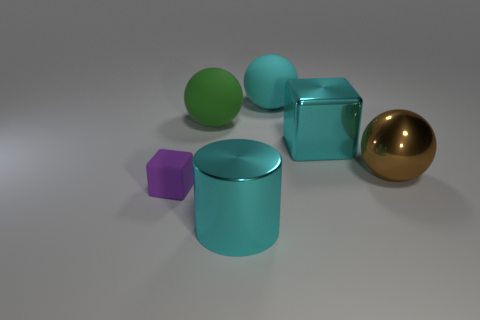Add 4 large cyan objects. How many objects exist? 10 Subtract all cylinders. How many objects are left? 5 Add 5 big metallic cylinders. How many big metallic cylinders exist? 6 Subtract 1 cyan balls. How many objects are left? 5 Subtract all big green rubber spheres. Subtract all brown shiny balls. How many objects are left? 4 Add 5 green spheres. How many green spheres are left? 6 